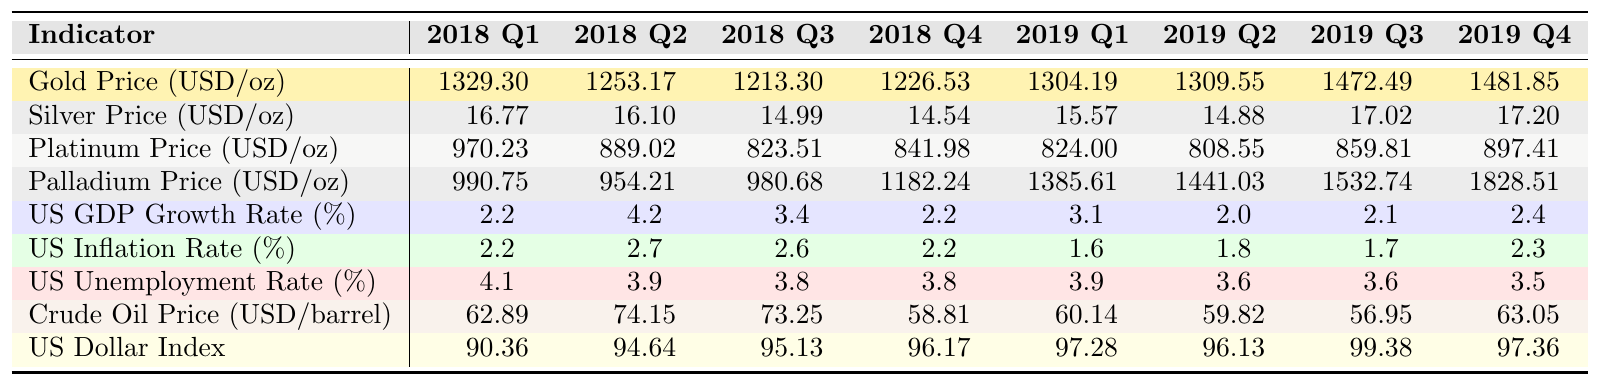What was the highest gold price recorded in 2019? In 2019, the gold prices are listed for each quarter: 1304.19 (Q1), 1309.55 (Q2), 1472.49 (Q3), and 1481.85 (Q4). The highest value among these is 1481.85 in Q4.
Answer: 1481.85 Which quarter had the lowest silver price? The silver prices for 2018 and 2019 are: 16.77 (Q1), 16.10 (Q2), 14.99 (Q3), 14.54 (Q4), 15.57 (Q1), 14.88 (Q2), 17.02 (Q3), and 17.20 (Q4). The lowest price is 14.54 in Q4 2018.
Answer: Q4 2018 What was the US GDP growth rate in 2018 Q2? According to the table, the US GDP growth rate for Q2 2018 is 4.2%.
Answer: 4.2% Did the platinum price decrease from Q1 2018 to Q4 2018? The platinum prices for these quarters are: 970.23 (Q1), 889.02 (Q2), 823.51 (Q3), and 841.98 (Q4). The price decreased from Q1 to Q3 and then increased in Q4, but it did not exceed the price in Q1; hence, yes, there was a decrease during that period.
Answer: Yes What is the average palladium price over the four quarters of 2019? The palladium prices in 2019 are: 1385.61 (Q1), 1441.03 (Q2), 1532.74 (Q3), and 1828.51 (Q4). The sum is 1385.61 + 1441.03 + 1532.74 + 1828.51 = 5187.89. There are four quarters, so the average is 5187.89 / 4 = 1296.97.
Answer: 1296.97 Is there a correlation between the increase in gold prices and the decrease in the US unemployment rate from 2018 Q1 to 2019 Q4? Analyzing the data: gold price increased from 1329.30 in 2018 Q1 to 1481.85 in 2019 Q4, while the unemployment rate decreased from 4.1% to 3.5%. This indicates a potential inverse correlation; as gold prices increased, the unemployment rate decreased.
Answer: Yes What was the change in crude oil prices from 2018 Q1 to 2019 Q4? The crude oil prices are 62.89 (2018 Q1) and 63.05 (2019 Q4). The change in price is 63.05 - 62.89 = 0.16, indicating a slight increase.
Answer: 0.16 During which quarter did the US dollar index reach its highest value? The US dollar index values for 2018 Q1 to 2019 Q4 are: 90.36 (Q1), 94.64 (Q2), 95.13 (Q3), 96.17 (Q4), 97.28 (Q1), 96.13 (Q2), 99.38 (Q3), and 97.36 (Q4). The highest value is 99.38 in 2019 Q3.
Answer: 2019 Q3 What percentage increase did gold prices experience from 2018 Q4 to 2019 Q3? From 2018 Q4 to 2019 Q3, the prices are 1226.53 and 1472.49. The increase is 1472.49 - 1226.53 = 245.96. To find the percentage increase: (245.96 / 1226.53) * 100 ≈ 20.08%.
Answer: 20.08% 